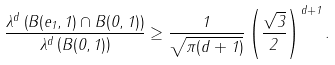Convert formula to latex. <formula><loc_0><loc_0><loc_500><loc_500>\frac { \lambda ^ { d } \left ( B ( e _ { 1 } , 1 ) \cap B ( 0 , 1 ) \right ) } { \lambda ^ { d } \left ( B ( 0 , 1 ) \right ) } \geq \frac { 1 } { \sqrt { \pi ( d + 1 ) } } \left ( \frac { \sqrt { 3 } } { 2 } \right ) ^ { d + 1 } .</formula> 